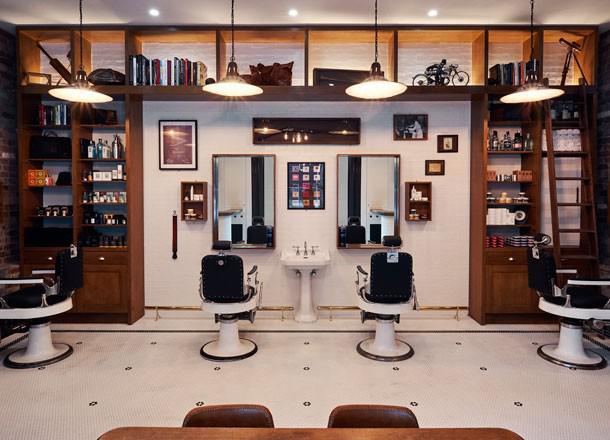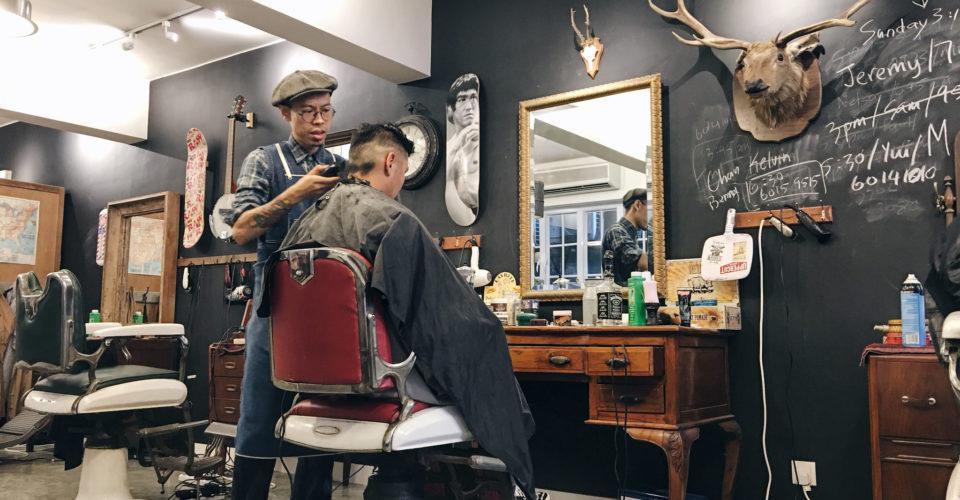The first image is the image on the left, the second image is the image on the right. Assess this claim about the two images: "There are at least two people in the image on the right.". Correct or not? Answer yes or no. Yes. The first image is the image on the left, the second image is the image on the right. For the images displayed, is the sentence "At least four round lights hang from the ceiling in one of the images." factually correct? Answer yes or no. Yes. 